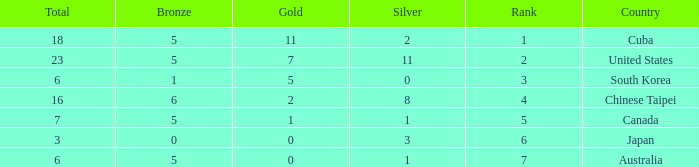What is the sum of the bronze medals when there were more than 2 silver medals and a rank larger than 6? None. 